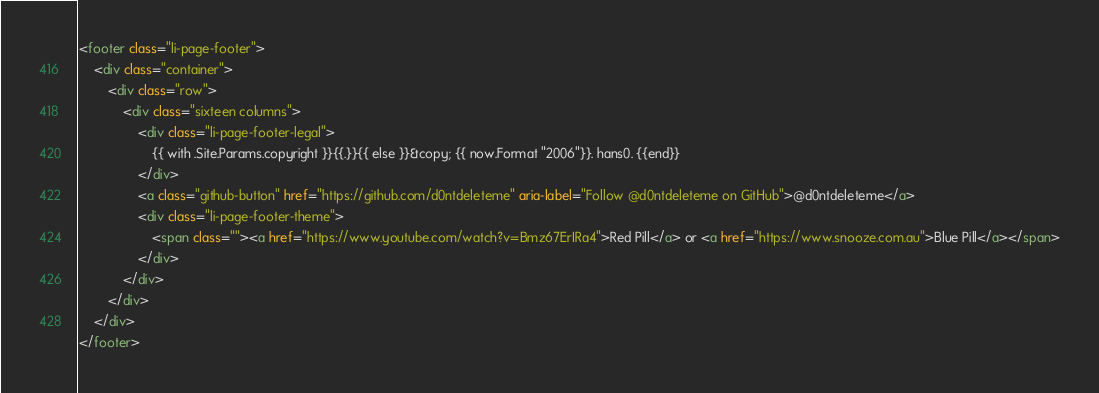<code> <loc_0><loc_0><loc_500><loc_500><_HTML_><footer class="li-page-footer">
    <div class="container">
        <div class="row">
            <div class="sixteen columns">
                <div class="li-page-footer-legal">
                    {{ with .Site.Params.copyright }}{{.}}{{ else }}&copy; {{ now.Format "2006"}}. hans0. {{end}}
                </div>
                <a class="github-button" href="https://github.com/d0ntdeleteme" aria-label="Follow @d0ntdeleteme on GitHub">@d0ntdeleteme</a>
                <div class="li-page-footer-theme">
                    <span class=""><a href="https://www.youtube.com/watch?v=Bmz67ErIRa4">Red Pill</a> or <a href="https://www.snooze.com.au">Blue Pill</a></span>
                </div>
            </div>
        </div>
    </div>
</footer>
</code> 